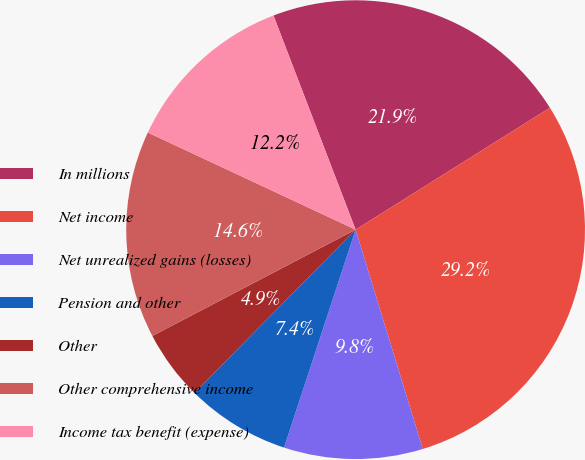<chart> <loc_0><loc_0><loc_500><loc_500><pie_chart><fcel>In millions<fcel>Net income<fcel>Net unrealized gains (losses)<fcel>Pension and other<fcel>Other<fcel>Other comprehensive income<fcel>Income tax benefit (expense)<nl><fcel>21.91%<fcel>29.19%<fcel>9.78%<fcel>7.35%<fcel>4.93%<fcel>14.63%<fcel>12.21%<nl></chart> 